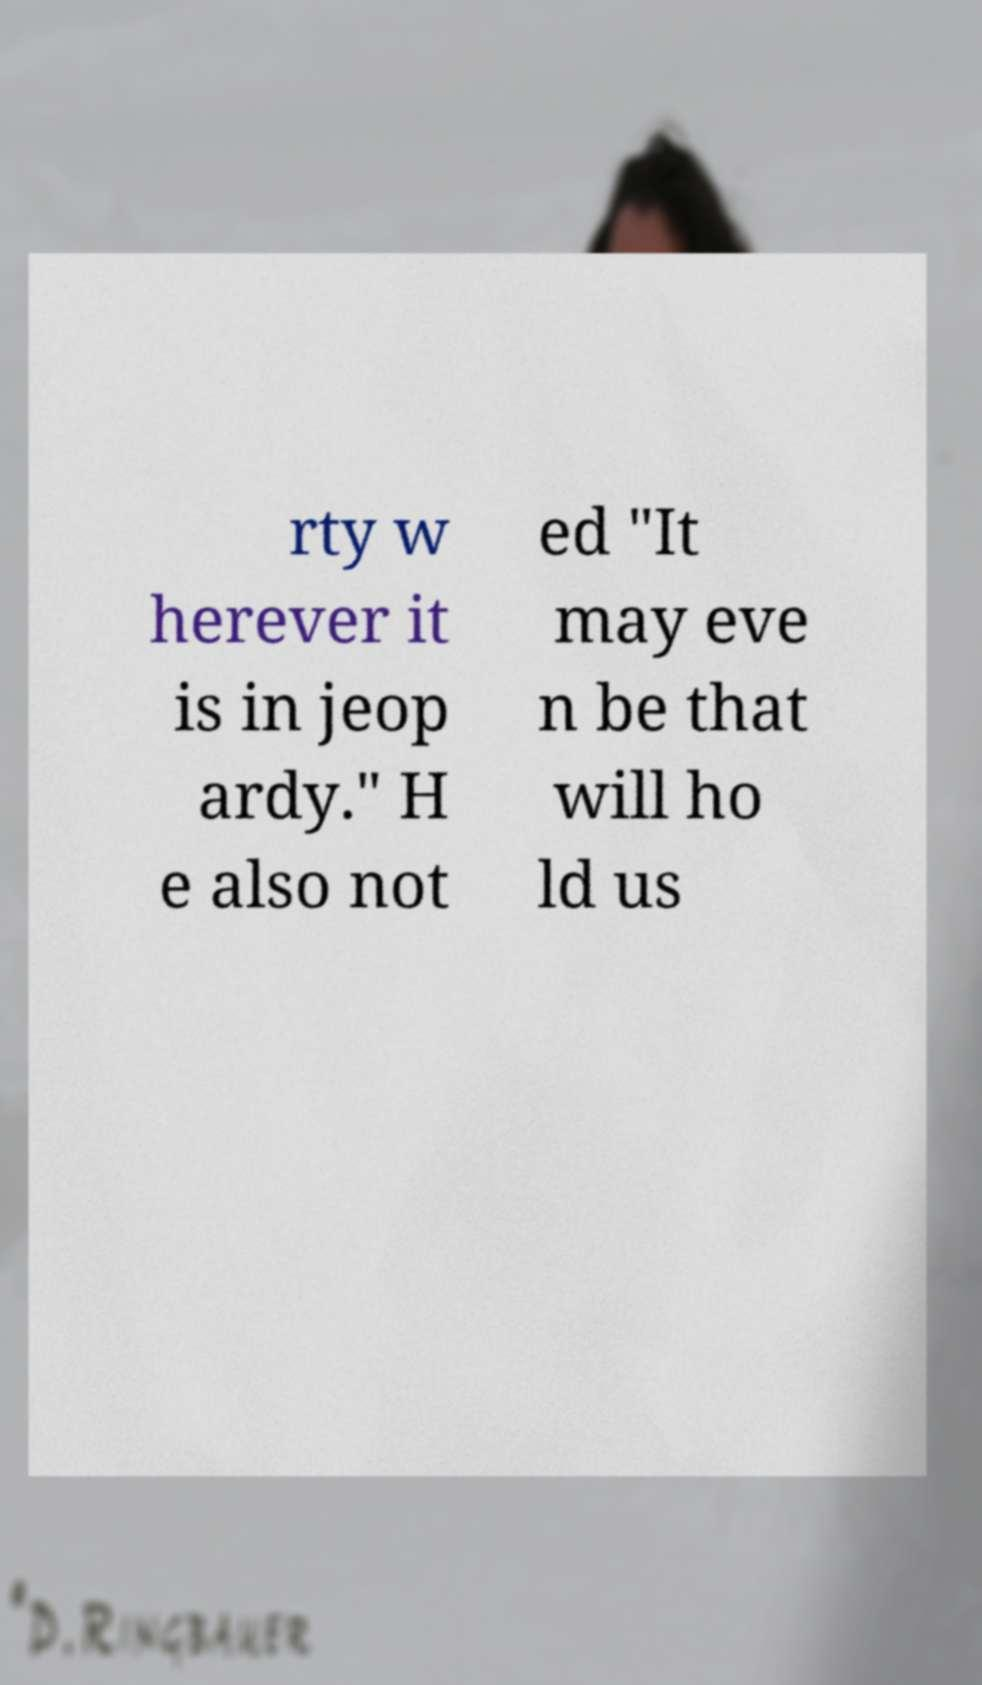Please read and relay the text visible in this image. What does it say? rty w herever it is in jeop ardy." H e also not ed "It may eve n be that will ho ld us 